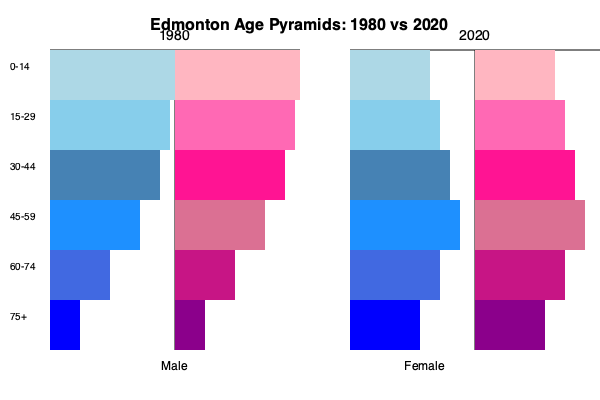Based on the age pyramid graphs for Edmonton in 1980 and 2020, what is the most significant demographic change you've observed over the past 40 years? To answer this question, we need to analyze the age pyramids for Edmonton in 1980 and 2020, comparing the distribution of population across different age groups:

1. Shape change:
   - 1980: The pyramid has a wider base and narrows towards the top, indicating a younger population.
   - 2020: The pyramid is more rectangular, suggesting a more evenly distributed population across age groups.

2. Young population (0-14 years):
   - 1980: Largest age group, wide base of the pyramid.
   - 2020: Significantly smaller proportion, narrower base.

3. Working-age population (30-59 years):
   - 1980: Smaller proportion compared to younger groups.
   - 2020: Larger proportion, especially in the 45-59 age group.

4. Elderly population (60+ years):
   - 1980: Very small proportion, narrow top of the pyramid.
   - 2020: Significantly larger proportion, wider top of the pyramid.

5. Gender distribution:
   - Both years show a relatively balanced gender distribution across age groups.

The most significant change observed is the aging of the population. This is evident from:
a) The decrease in the proportion of young people (0-14 years).
b) The increase in the proportion of older adults and seniors (60+ years).
c) The shift from a pyramid shape (1980) to a more rectangular shape (2020).

This aging trend is likely due to factors such as:
- Declining birth rates
- Increased life expectancy
- The aging of the large cohort of baby boomers
Answer: Aging population: decrease in youth, increase in seniors 